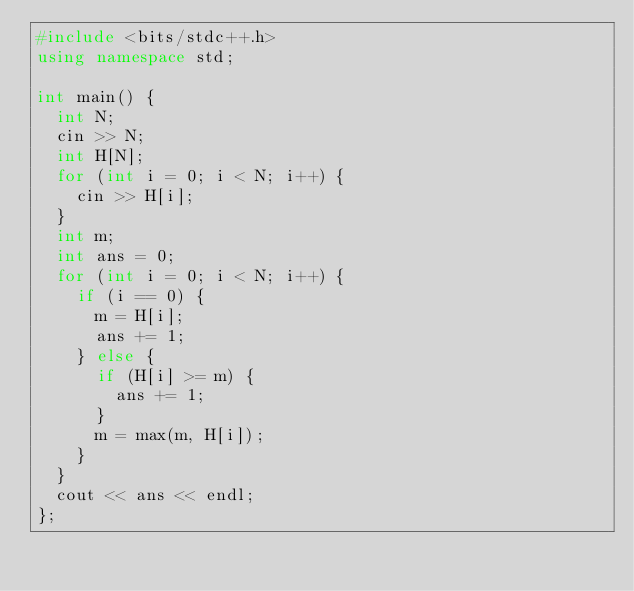Convert code to text. <code><loc_0><loc_0><loc_500><loc_500><_C++_>#include <bits/stdc++.h>
using namespace std;

int main() {
  int N;
  cin >> N;
  int H[N];
  for (int i = 0; i < N; i++) {
    cin >> H[i];
  }
  int m;
  int ans = 0;
  for (int i = 0; i < N; i++) {
    if (i == 0) {
      m = H[i];
      ans += 1;
    } else {
      if (H[i] >= m) {
        ans += 1;
      }
      m = max(m, H[i]);
    }
  }
  cout << ans << endl;
};
</code> 